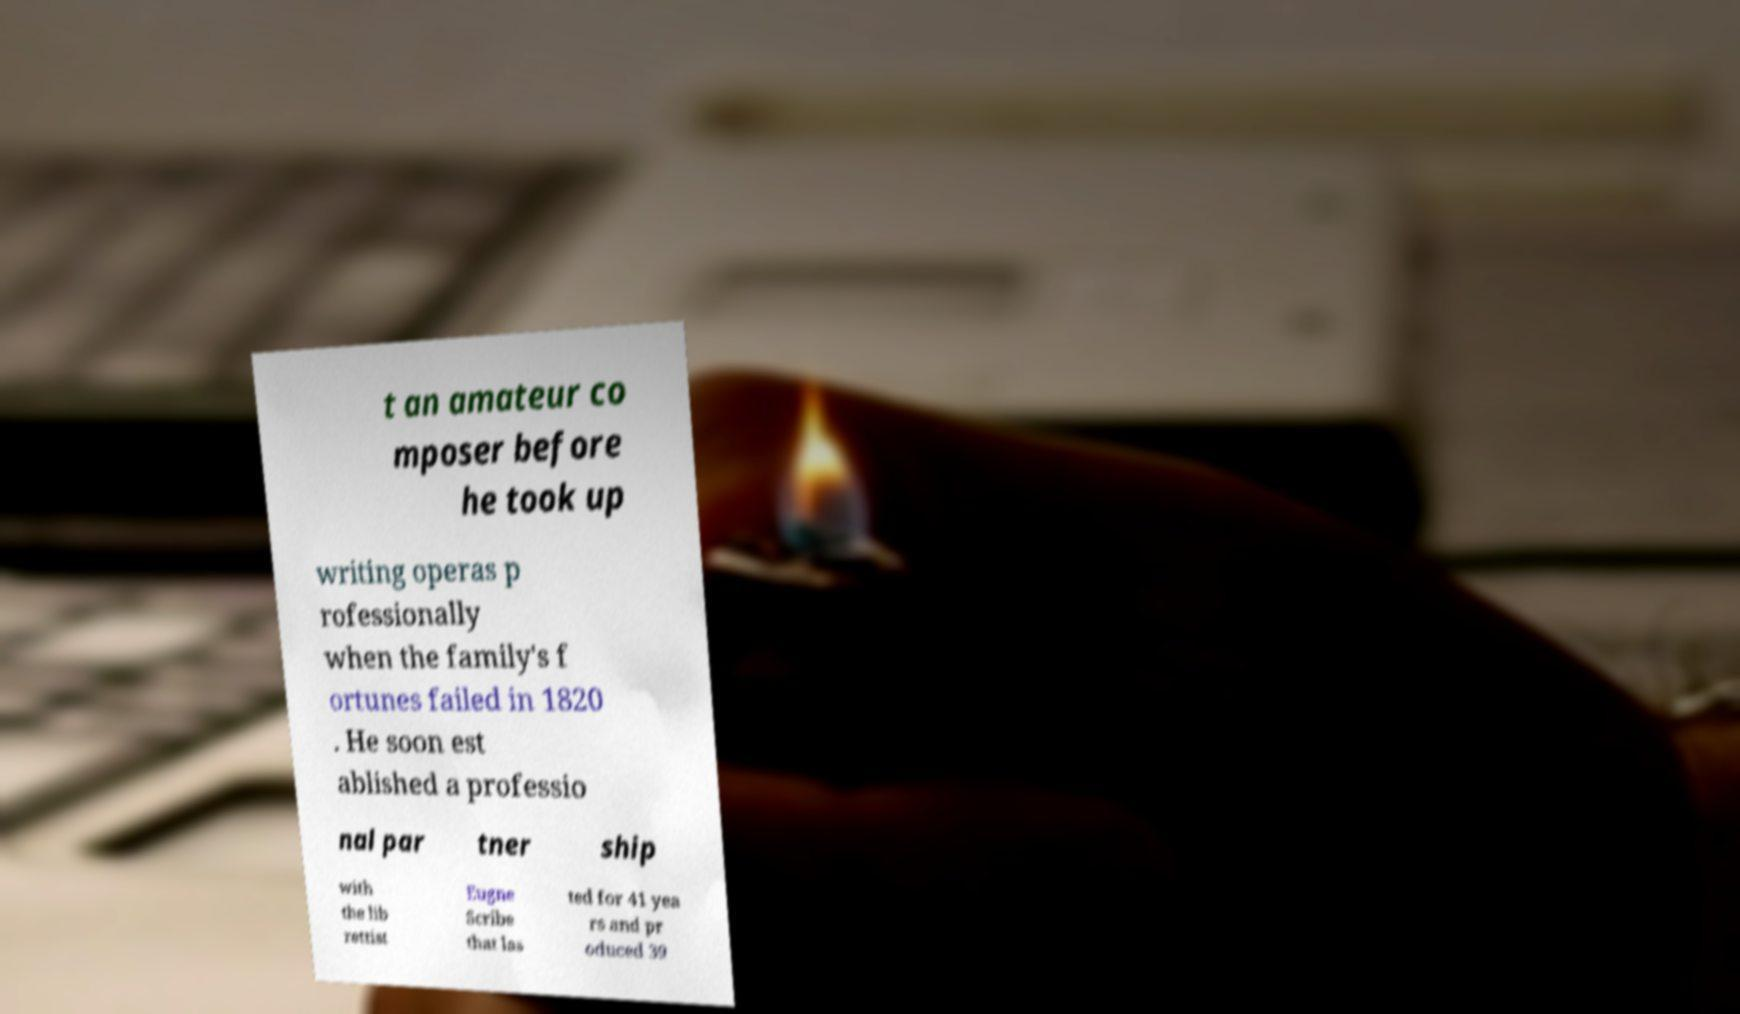Can you read and provide the text displayed in the image?This photo seems to have some interesting text. Can you extract and type it out for me? t an amateur co mposer before he took up writing operas p rofessionally when the family's f ortunes failed in 1820 . He soon est ablished a professio nal par tner ship with the lib rettist Eugne Scribe that las ted for 41 yea rs and pr oduced 39 